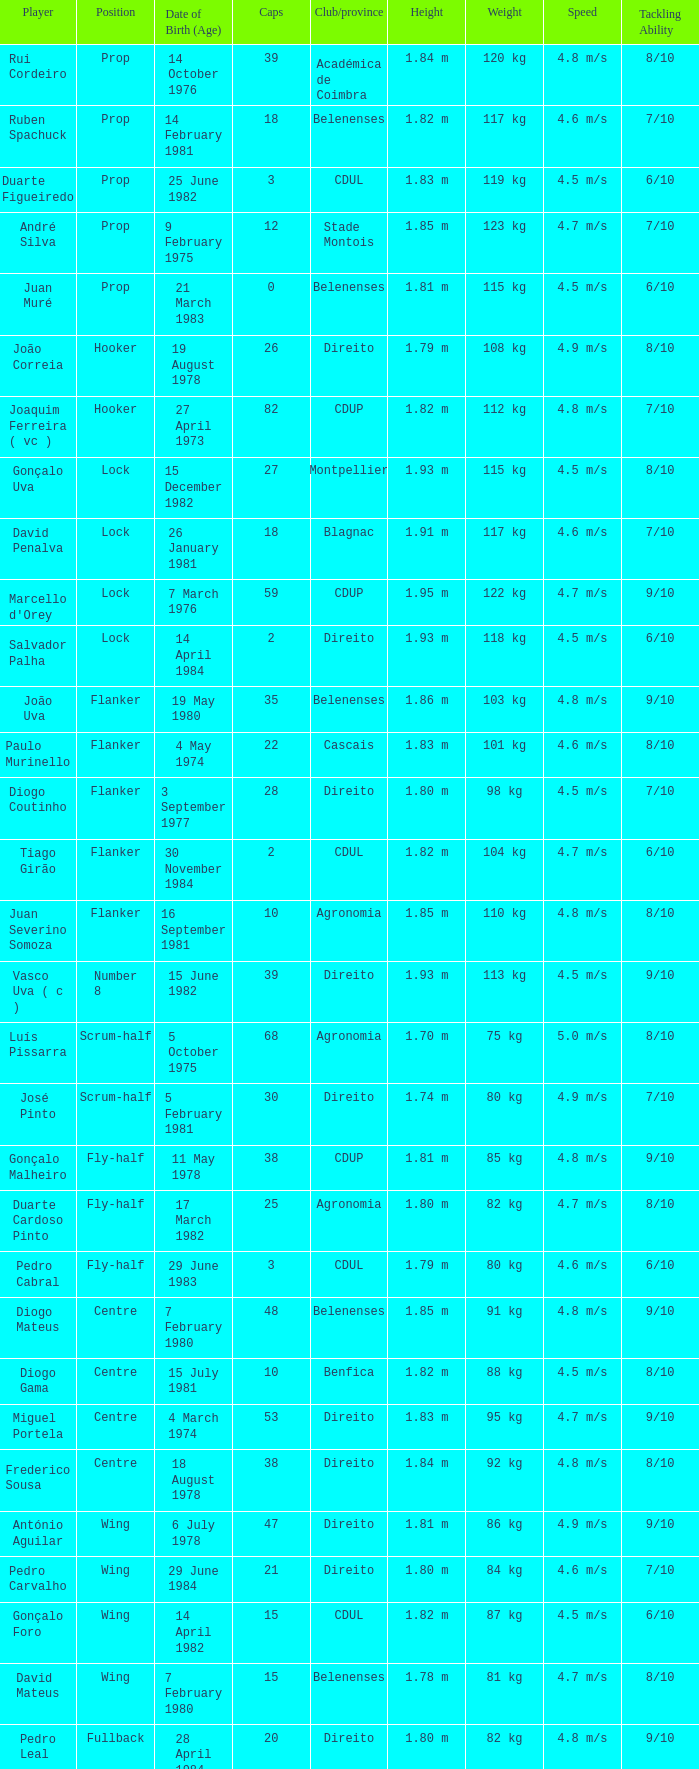Which Club/province has a Player of david penalva? Blagnac. 